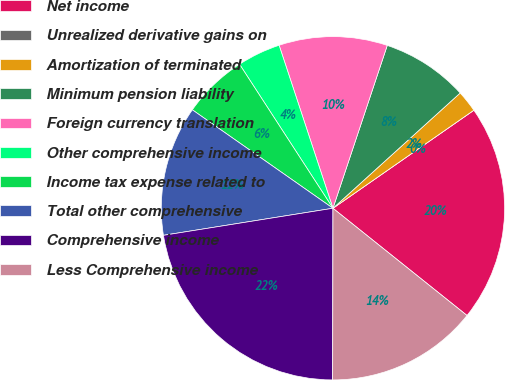Convert chart. <chart><loc_0><loc_0><loc_500><loc_500><pie_chart><fcel>Net income<fcel>Unrealized derivative gains on<fcel>Amortization of terminated<fcel>Minimum pension liability<fcel>Foreign currency translation<fcel>Other comprehensive income<fcel>Income tax expense related to<fcel>Total other comprehensive<fcel>Comprehensive income<fcel>Less Comprehensive income<nl><fcel>20.41%<fcel>0.0%<fcel>2.04%<fcel>8.16%<fcel>10.2%<fcel>4.08%<fcel>6.12%<fcel>12.24%<fcel>22.45%<fcel>14.29%<nl></chart> 